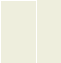<code> <loc_0><loc_0><loc_500><loc_500><_PHP_>

</code> 